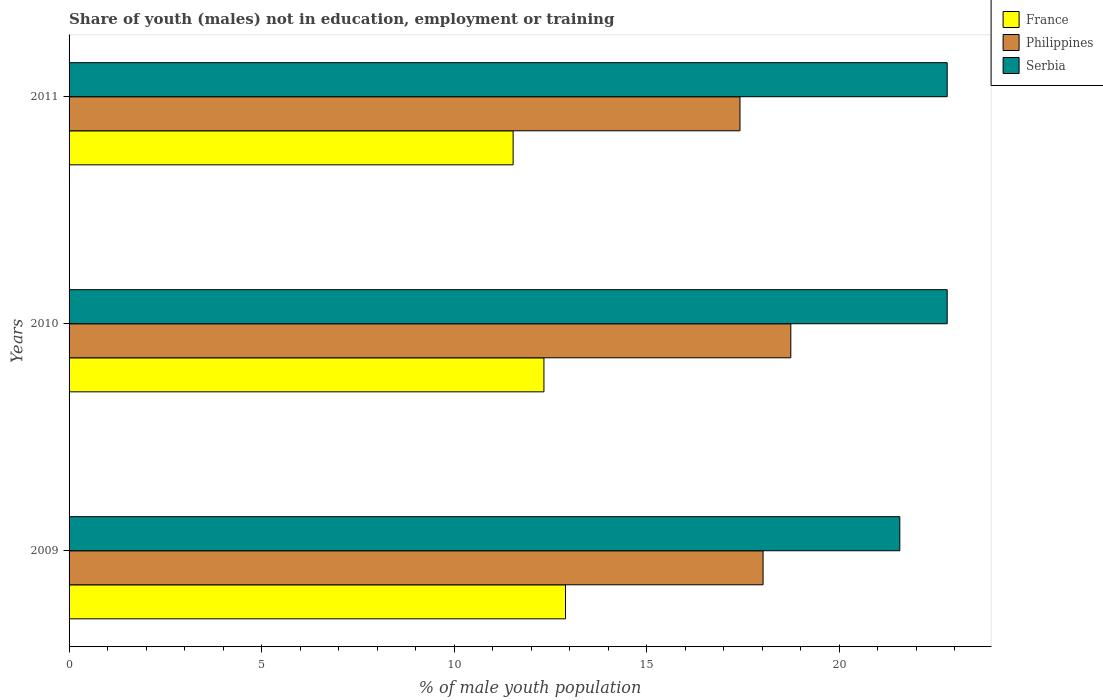How many groups of bars are there?
Make the answer very short. 3. Are the number of bars on each tick of the Y-axis equal?
Make the answer very short. Yes. How many bars are there on the 3rd tick from the top?
Give a very brief answer. 3. How many bars are there on the 2nd tick from the bottom?
Your response must be concise. 3. In how many cases, is the number of bars for a given year not equal to the number of legend labels?
Keep it short and to the point. 0. What is the percentage of unemployed males population in in France in 2011?
Your answer should be compact. 11.53. Across all years, what is the maximum percentage of unemployed males population in in France?
Make the answer very short. 12.89. Across all years, what is the minimum percentage of unemployed males population in in Serbia?
Offer a terse response. 21.57. In which year was the percentage of unemployed males population in in Philippines maximum?
Provide a short and direct response. 2010. In which year was the percentage of unemployed males population in in France minimum?
Provide a short and direct response. 2011. What is the total percentage of unemployed males population in in Serbia in the graph?
Your answer should be compact. 67.17. What is the difference between the percentage of unemployed males population in in France in 2009 and that in 2011?
Provide a short and direct response. 1.36. What is the difference between the percentage of unemployed males population in in Serbia in 2009 and the percentage of unemployed males population in in Philippines in 2011?
Keep it short and to the point. 4.15. What is the average percentage of unemployed males population in in Serbia per year?
Provide a short and direct response. 22.39. In the year 2009, what is the difference between the percentage of unemployed males population in in Serbia and percentage of unemployed males population in in France?
Make the answer very short. 8.68. What is the ratio of the percentage of unemployed males population in in Serbia in 2009 to that in 2011?
Offer a terse response. 0.95. Is the percentage of unemployed males population in in France in 2009 less than that in 2011?
Provide a succinct answer. No. Is the difference between the percentage of unemployed males population in in Serbia in 2009 and 2011 greater than the difference between the percentage of unemployed males population in in France in 2009 and 2011?
Your answer should be very brief. No. What is the difference between the highest and the lowest percentage of unemployed males population in in France?
Give a very brief answer. 1.36. In how many years, is the percentage of unemployed males population in in Serbia greater than the average percentage of unemployed males population in in Serbia taken over all years?
Give a very brief answer. 2. Is the sum of the percentage of unemployed males population in in Serbia in 2009 and 2010 greater than the maximum percentage of unemployed males population in in Philippines across all years?
Give a very brief answer. Yes. What does the 1st bar from the top in 2011 represents?
Keep it short and to the point. Serbia. What does the 2nd bar from the bottom in 2011 represents?
Provide a short and direct response. Philippines. Is it the case that in every year, the sum of the percentage of unemployed males population in in Philippines and percentage of unemployed males population in in Serbia is greater than the percentage of unemployed males population in in France?
Give a very brief answer. Yes. How many bars are there?
Your answer should be very brief. 9. Are all the bars in the graph horizontal?
Offer a terse response. Yes. How many years are there in the graph?
Your answer should be very brief. 3. What is the difference between two consecutive major ticks on the X-axis?
Your answer should be compact. 5. Are the values on the major ticks of X-axis written in scientific E-notation?
Offer a very short reply. No. Does the graph contain any zero values?
Your answer should be compact. No. Where does the legend appear in the graph?
Offer a terse response. Top right. What is the title of the graph?
Provide a succinct answer. Share of youth (males) not in education, employment or training. Does "American Samoa" appear as one of the legend labels in the graph?
Give a very brief answer. No. What is the label or title of the X-axis?
Make the answer very short. % of male youth population. What is the label or title of the Y-axis?
Provide a short and direct response. Years. What is the % of male youth population in France in 2009?
Keep it short and to the point. 12.89. What is the % of male youth population in Philippines in 2009?
Give a very brief answer. 18.02. What is the % of male youth population of Serbia in 2009?
Make the answer very short. 21.57. What is the % of male youth population of France in 2010?
Your answer should be very brief. 12.33. What is the % of male youth population in Philippines in 2010?
Your answer should be very brief. 18.74. What is the % of male youth population in Serbia in 2010?
Your answer should be compact. 22.8. What is the % of male youth population in France in 2011?
Keep it short and to the point. 11.53. What is the % of male youth population of Philippines in 2011?
Ensure brevity in your answer.  17.42. What is the % of male youth population in Serbia in 2011?
Your answer should be very brief. 22.8. Across all years, what is the maximum % of male youth population of France?
Ensure brevity in your answer.  12.89. Across all years, what is the maximum % of male youth population in Philippines?
Your answer should be very brief. 18.74. Across all years, what is the maximum % of male youth population of Serbia?
Provide a succinct answer. 22.8. Across all years, what is the minimum % of male youth population in France?
Your answer should be compact. 11.53. Across all years, what is the minimum % of male youth population in Philippines?
Your answer should be very brief. 17.42. Across all years, what is the minimum % of male youth population in Serbia?
Ensure brevity in your answer.  21.57. What is the total % of male youth population in France in the graph?
Provide a short and direct response. 36.75. What is the total % of male youth population in Philippines in the graph?
Keep it short and to the point. 54.18. What is the total % of male youth population in Serbia in the graph?
Provide a succinct answer. 67.17. What is the difference between the % of male youth population of France in 2009 and that in 2010?
Provide a short and direct response. 0.56. What is the difference between the % of male youth population in Philippines in 2009 and that in 2010?
Give a very brief answer. -0.72. What is the difference between the % of male youth population of Serbia in 2009 and that in 2010?
Provide a succinct answer. -1.23. What is the difference between the % of male youth population in France in 2009 and that in 2011?
Offer a terse response. 1.36. What is the difference between the % of male youth population of Philippines in 2009 and that in 2011?
Make the answer very short. 0.6. What is the difference between the % of male youth population in Serbia in 2009 and that in 2011?
Offer a very short reply. -1.23. What is the difference between the % of male youth population in Philippines in 2010 and that in 2011?
Offer a very short reply. 1.32. What is the difference between the % of male youth population of France in 2009 and the % of male youth population of Philippines in 2010?
Provide a succinct answer. -5.85. What is the difference between the % of male youth population in France in 2009 and the % of male youth population in Serbia in 2010?
Keep it short and to the point. -9.91. What is the difference between the % of male youth population in Philippines in 2009 and the % of male youth population in Serbia in 2010?
Give a very brief answer. -4.78. What is the difference between the % of male youth population in France in 2009 and the % of male youth population in Philippines in 2011?
Offer a terse response. -4.53. What is the difference between the % of male youth population of France in 2009 and the % of male youth population of Serbia in 2011?
Give a very brief answer. -9.91. What is the difference between the % of male youth population in Philippines in 2009 and the % of male youth population in Serbia in 2011?
Your response must be concise. -4.78. What is the difference between the % of male youth population of France in 2010 and the % of male youth population of Philippines in 2011?
Offer a terse response. -5.09. What is the difference between the % of male youth population of France in 2010 and the % of male youth population of Serbia in 2011?
Make the answer very short. -10.47. What is the difference between the % of male youth population in Philippines in 2010 and the % of male youth population in Serbia in 2011?
Your answer should be compact. -4.06. What is the average % of male youth population of France per year?
Provide a short and direct response. 12.25. What is the average % of male youth population of Philippines per year?
Offer a very short reply. 18.06. What is the average % of male youth population in Serbia per year?
Offer a very short reply. 22.39. In the year 2009, what is the difference between the % of male youth population in France and % of male youth population in Philippines?
Provide a short and direct response. -5.13. In the year 2009, what is the difference between the % of male youth population of France and % of male youth population of Serbia?
Your answer should be very brief. -8.68. In the year 2009, what is the difference between the % of male youth population in Philippines and % of male youth population in Serbia?
Keep it short and to the point. -3.55. In the year 2010, what is the difference between the % of male youth population in France and % of male youth population in Philippines?
Provide a succinct answer. -6.41. In the year 2010, what is the difference between the % of male youth population of France and % of male youth population of Serbia?
Keep it short and to the point. -10.47. In the year 2010, what is the difference between the % of male youth population of Philippines and % of male youth population of Serbia?
Provide a short and direct response. -4.06. In the year 2011, what is the difference between the % of male youth population of France and % of male youth population of Philippines?
Your answer should be very brief. -5.89. In the year 2011, what is the difference between the % of male youth population of France and % of male youth population of Serbia?
Your response must be concise. -11.27. In the year 2011, what is the difference between the % of male youth population of Philippines and % of male youth population of Serbia?
Offer a very short reply. -5.38. What is the ratio of the % of male youth population in France in 2009 to that in 2010?
Offer a very short reply. 1.05. What is the ratio of the % of male youth population in Philippines in 2009 to that in 2010?
Your answer should be compact. 0.96. What is the ratio of the % of male youth population in Serbia in 2009 to that in 2010?
Offer a terse response. 0.95. What is the ratio of the % of male youth population in France in 2009 to that in 2011?
Your answer should be compact. 1.12. What is the ratio of the % of male youth population in Philippines in 2009 to that in 2011?
Ensure brevity in your answer.  1.03. What is the ratio of the % of male youth population of Serbia in 2009 to that in 2011?
Your answer should be very brief. 0.95. What is the ratio of the % of male youth population of France in 2010 to that in 2011?
Provide a succinct answer. 1.07. What is the ratio of the % of male youth population in Philippines in 2010 to that in 2011?
Your response must be concise. 1.08. What is the ratio of the % of male youth population in Serbia in 2010 to that in 2011?
Give a very brief answer. 1. What is the difference between the highest and the second highest % of male youth population in France?
Offer a terse response. 0.56. What is the difference between the highest and the second highest % of male youth population of Philippines?
Offer a very short reply. 0.72. What is the difference between the highest and the second highest % of male youth population of Serbia?
Give a very brief answer. 0. What is the difference between the highest and the lowest % of male youth population of France?
Make the answer very short. 1.36. What is the difference between the highest and the lowest % of male youth population of Philippines?
Your response must be concise. 1.32. What is the difference between the highest and the lowest % of male youth population of Serbia?
Keep it short and to the point. 1.23. 